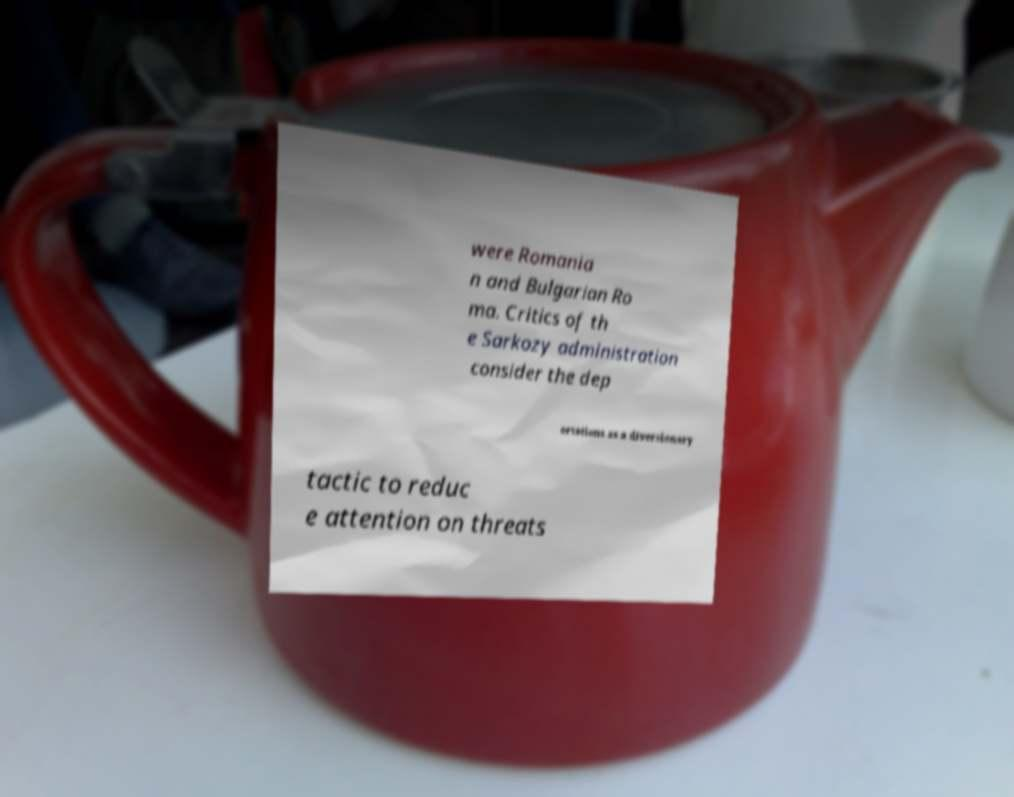What messages or text are displayed in this image? I need them in a readable, typed format. were Romania n and Bulgarian Ro ma. Critics of th e Sarkozy administration consider the dep ortations as a diversionary tactic to reduc e attention on threats 